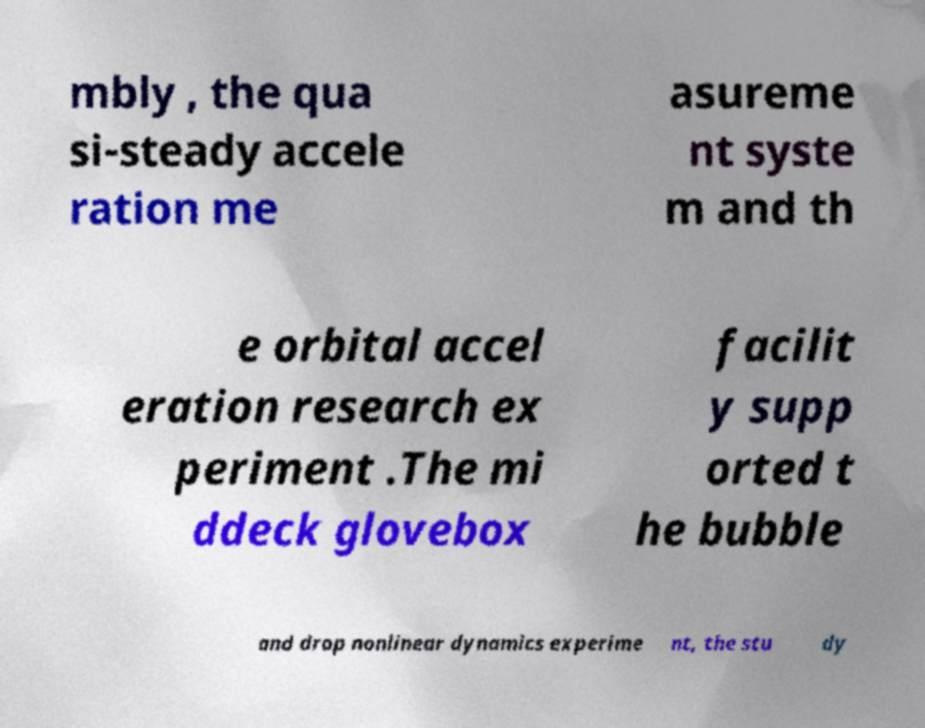What messages or text are displayed in this image? I need them in a readable, typed format. mbly , the qua si-steady accele ration me asureme nt syste m and th e orbital accel eration research ex periment .The mi ddeck glovebox facilit y supp orted t he bubble and drop nonlinear dynamics experime nt, the stu dy 